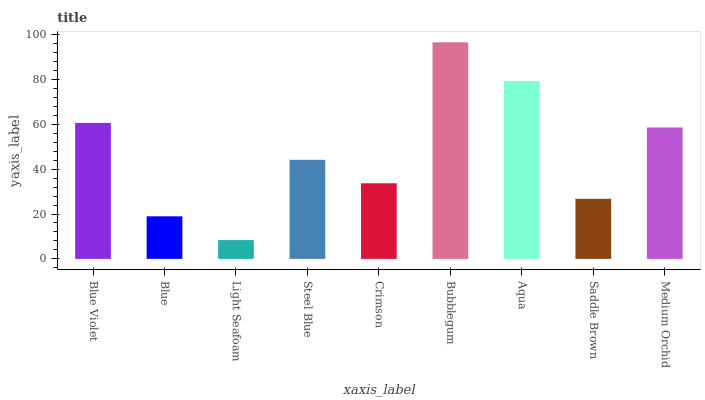Is Blue the minimum?
Answer yes or no. No. Is Blue the maximum?
Answer yes or no. No. Is Blue Violet greater than Blue?
Answer yes or no. Yes. Is Blue less than Blue Violet?
Answer yes or no. Yes. Is Blue greater than Blue Violet?
Answer yes or no. No. Is Blue Violet less than Blue?
Answer yes or no. No. Is Steel Blue the high median?
Answer yes or no. Yes. Is Steel Blue the low median?
Answer yes or no. Yes. Is Light Seafoam the high median?
Answer yes or no. No. Is Aqua the low median?
Answer yes or no. No. 